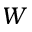Convert formula to latex. <formula><loc_0><loc_0><loc_500><loc_500>W</formula> 